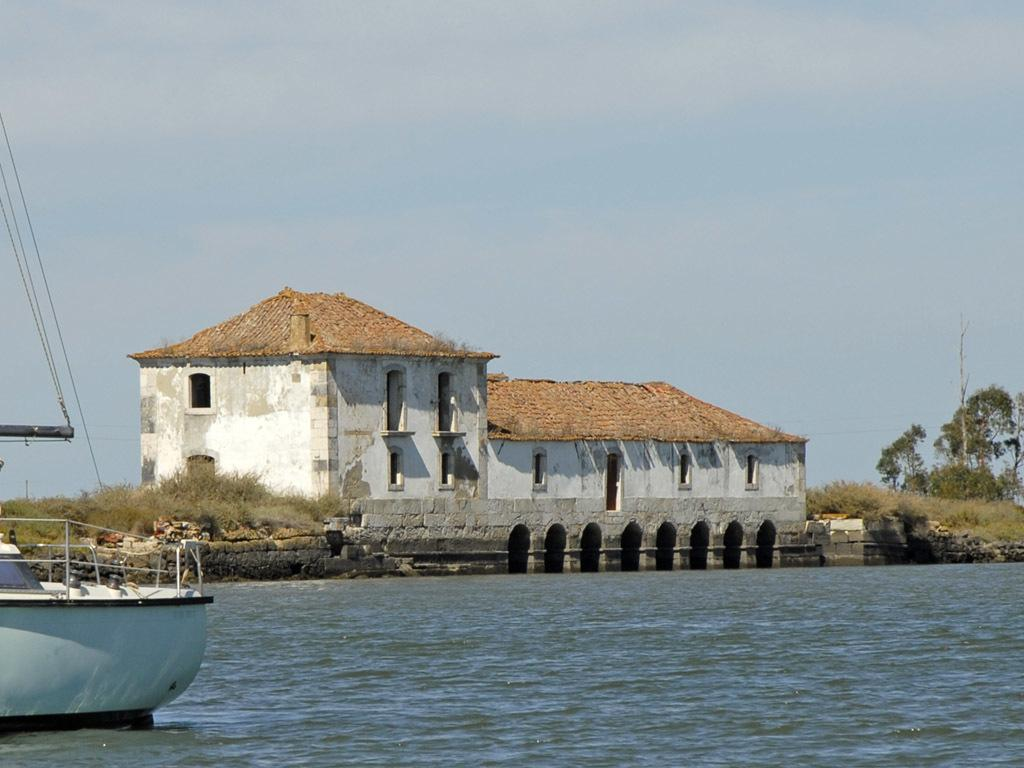What type of structure is shown in the image? The image appears to depict a house. What type of vegetation is present in the image? There are trees and grass in the image. What can be seen on the left side of the image? On the left side of the image, there is a boat on the water. What is visible in the background of the image? The sky is visible in the image. How many toes can be seen on the house in the image? There are no toes present in the image, as it depicts a house and not a person or animal. 